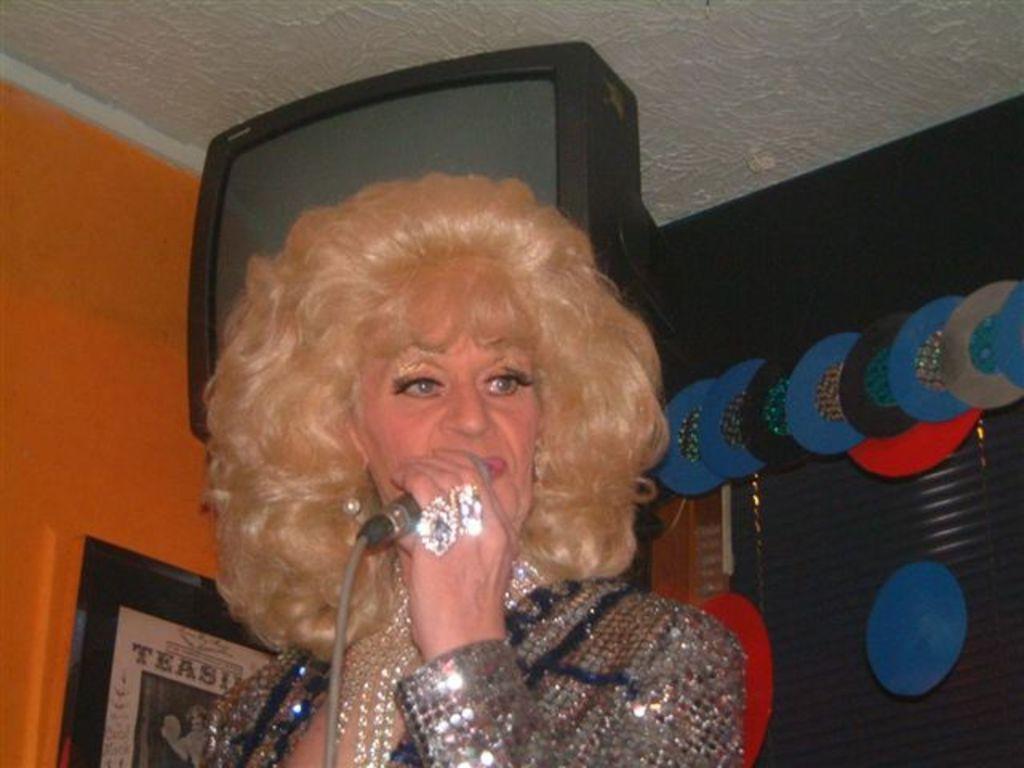Can you describe this image briefly? In the center of the image we can see one woman standing and she is holding a microphone. And she is in different costume. In the background there is a wall, roof, monitor, photo frame, shutter, blue and black color round objects and a few other objects. 